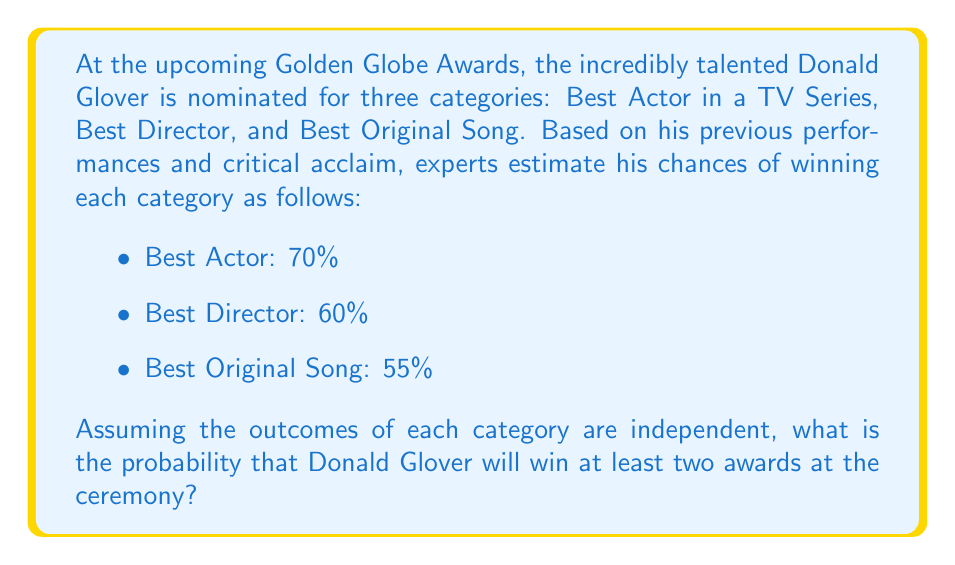Solve this math problem. Let's approach this step-by-step:

1) First, we need to calculate the probability of Donald Glover winning exactly 0, 1, 2, or 3 awards.

2) Let's use $P(A)$, $P(D)$, and $P(S)$ to represent the probabilities of winning Actor, Director, and Song awards respectively.

3) Probability of winning exactly 3 awards:
   $$P(3) = P(A) \times P(D) \times P(S) = 0.70 \times 0.60 \times 0.55 = 0.231$$

4) Probability of winning exactly 2 awards:
   $$P(2) = P(A)P(D)(1-P(S)) + P(A)(1-P(D))P(S) + (1-P(A))P(D)P(S)$$
   $$= 0.70 \times 0.60 \times 0.45 + 0.70 \times 0.40 \times 0.55 + 0.30 \times 0.60 \times 0.55$$
   $$= 0.189 + 0.154 + 0.099 = 0.442$$

5) The probability of winning at least two awards is the sum of the probabilities of winning exactly 2 and exactly 3 awards:

   $$P(\text{at least 2}) = P(2) + P(3) = 0.442 + 0.231 = 0.673$$

6) Therefore, the probability of Donald Glover winning at least two awards is 0.673 or 67.3%.
Answer: 0.673 or 67.3% 